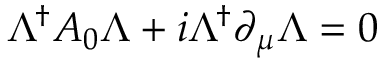<formula> <loc_0><loc_0><loc_500><loc_500>\Lambda ^ { \dagger } A _ { 0 } \Lambda + i \Lambda ^ { \dagger } \partial _ { \mu } \Lambda = 0</formula> 